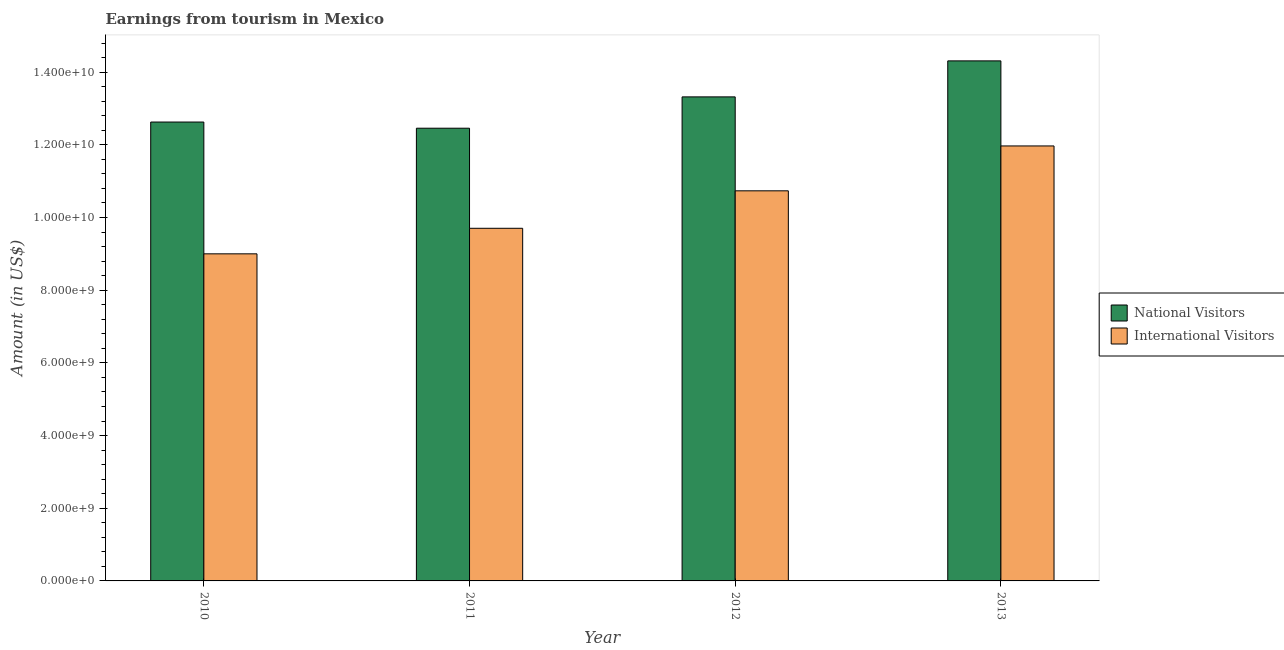How many groups of bars are there?
Your answer should be compact. 4. Are the number of bars per tick equal to the number of legend labels?
Your answer should be very brief. Yes. How many bars are there on the 2nd tick from the left?
Provide a short and direct response. 2. What is the label of the 1st group of bars from the left?
Make the answer very short. 2010. What is the amount earned from international visitors in 2012?
Ensure brevity in your answer.  1.07e+1. Across all years, what is the maximum amount earned from international visitors?
Ensure brevity in your answer.  1.20e+1. Across all years, what is the minimum amount earned from international visitors?
Provide a short and direct response. 9.00e+09. In which year was the amount earned from national visitors maximum?
Make the answer very short. 2013. In which year was the amount earned from international visitors minimum?
Give a very brief answer. 2010. What is the total amount earned from international visitors in the graph?
Keep it short and to the point. 4.14e+1. What is the difference between the amount earned from international visitors in 2012 and that in 2013?
Your response must be concise. -1.24e+09. What is the difference between the amount earned from national visitors in 2013 and the amount earned from international visitors in 2010?
Give a very brief answer. 1.68e+09. What is the average amount earned from international visitors per year?
Offer a very short reply. 1.04e+1. What is the ratio of the amount earned from national visitors in 2012 to that in 2013?
Provide a short and direct response. 0.93. What is the difference between the highest and the second highest amount earned from international visitors?
Your answer should be compact. 1.24e+09. What is the difference between the highest and the lowest amount earned from national visitors?
Your response must be concise. 1.85e+09. What does the 2nd bar from the left in 2013 represents?
Offer a terse response. International Visitors. What does the 2nd bar from the right in 2011 represents?
Your response must be concise. National Visitors. How many bars are there?
Keep it short and to the point. 8. Are all the bars in the graph horizontal?
Keep it short and to the point. No. How many years are there in the graph?
Make the answer very short. 4. Are the values on the major ticks of Y-axis written in scientific E-notation?
Keep it short and to the point. Yes. What is the title of the graph?
Provide a succinct answer. Earnings from tourism in Mexico. What is the label or title of the X-axis?
Provide a short and direct response. Year. What is the label or title of the Y-axis?
Provide a short and direct response. Amount (in US$). What is the Amount (in US$) in National Visitors in 2010?
Provide a succinct answer. 1.26e+1. What is the Amount (in US$) of International Visitors in 2010?
Offer a terse response. 9.00e+09. What is the Amount (in US$) of National Visitors in 2011?
Keep it short and to the point. 1.25e+1. What is the Amount (in US$) in International Visitors in 2011?
Ensure brevity in your answer.  9.70e+09. What is the Amount (in US$) of National Visitors in 2012?
Provide a succinct answer. 1.33e+1. What is the Amount (in US$) in International Visitors in 2012?
Provide a succinct answer. 1.07e+1. What is the Amount (in US$) in National Visitors in 2013?
Offer a terse response. 1.43e+1. What is the Amount (in US$) in International Visitors in 2013?
Provide a short and direct response. 1.20e+1. Across all years, what is the maximum Amount (in US$) in National Visitors?
Offer a very short reply. 1.43e+1. Across all years, what is the maximum Amount (in US$) in International Visitors?
Provide a short and direct response. 1.20e+1. Across all years, what is the minimum Amount (in US$) in National Visitors?
Offer a very short reply. 1.25e+1. Across all years, what is the minimum Amount (in US$) of International Visitors?
Give a very brief answer. 9.00e+09. What is the total Amount (in US$) of National Visitors in the graph?
Make the answer very short. 5.27e+1. What is the total Amount (in US$) in International Visitors in the graph?
Your response must be concise. 4.14e+1. What is the difference between the Amount (in US$) in National Visitors in 2010 and that in 2011?
Your response must be concise. 1.70e+08. What is the difference between the Amount (in US$) in International Visitors in 2010 and that in 2011?
Your response must be concise. -7.03e+08. What is the difference between the Amount (in US$) in National Visitors in 2010 and that in 2012?
Provide a short and direct response. -6.92e+08. What is the difference between the Amount (in US$) in International Visitors in 2010 and that in 2012?
Offer a very short reply. -1.73e+09. What is the difference between the Amount (in US$) in National Visitors in 2010 and that in 2013?
Provide a short and direct response. -1.68e+09. What is the difference between the Amount (in US$) of International Visitors in 2010 and that in 2013?
Provide a short and direct response. -2.97e+09. What is the difference between the Amount (in US$) of National Visitors in 2011 and that in 2012?
Provide a succinct answer. -8.62e+08. What is the difference between the Amount (in US$) in International Visitors in 2011 and that in 2012?
Give a very brief answer. -1.03e+09. What is the difference between the Amount (in US$) of National Visitors in 2011 and that in 2013?
Your answer should be very brief. -1.85e+09. What is the difference between the Amount (in US$) of International Visitors in 2011 and that in 2013?
Offer a terse response. -2.27e+09. What is the difference between the Amount (in US$) of National Visitors in 2012 and that in 2013?
Provide a succinct answer. -9.91e+08. What is the difference between the Amount (in US$) in International Visitors in 2012 and that in 2013?
Your answer should be compact. -1.24e+09. What is the difference between the Amount (in US$) of National Visitors in 2010 and the Amount (in US$) of International Visitors in 2011?
Your response must be concise. 2.92e+09. What is the difference between the Amount (in US$) in National Visitors in 2010 and the Amount (in US$) in International Visitors in 2012?
Provide a succinct answer. 1.89e+09. What is the difference between the Amount (in US$) in National Visitors in 2010 and the Amount (in US$) in International Visitors in 2013?
Offer a terse response. 6.58e+08. What is the difference between the Amount (in US$) in National Visitors in 2011 and the Amount (in US$) in International Visitors in 2012?
Provide a short and direct response. 1.72e+09. What is the difference between the Amount (in US$) in National Visitors in 2011 and the Amount (in US$) in International Visitors in 2013?
Make the answer very short. 4.88e+08. What is the difference between the Amount (in US$) in National Visitors in 2012 and the Amount (in US$) in International Visitors in 2013?
Your answer should be very brief. 1.35e+09. What is the average Amount (in US$) of National Visitors per year?
Your answer should be compact. 1.32e+1. What is the average Amount (in US$) in International Visitors per year?
Provide a short and direct response. 1.04e+1. In the year 2010, what is the difference between the Amount (in US$) of National Visitors and Amount (in US$) of International Visitors?
Give a very brief answer. 3.63e+09. In the year 2011, what is the difference between the Amount (in US$) in National Visitors and Amount (in US$) in International Visitors?
Your answer should be very brief. 2.75e+09. In the year 2012, what is the difference between the Amount (in US$) in National Visitors and Amount (in US$) in International Visitors?
Ensure brevity in your answer.  2.58e+09. In the year 2013, what is the difference between the Amount (in US$) of National Visitors and Amount (in US$) of International Visitors?
Make the answer very short. 2.34e+09. What is the ratio of the Amount (in US$) of National Visitors in 2010 to that in 2011?
Your answer should be very brief. 1.01. What is the ratio of the Amount (in US$) of International Visitors in 2010 to that in 2011?
Ensure brevity in your answer.  0.93. What is the ratio of the Amount (in US$) of National Visitors in 2010 to that in 2012?
Give a very brief answer. 0.95. What is the ratio of the Amount (in US$) of International Visitors in 2010 to that in 2012?
Offer a very short reply. 0.84. What is the ratio of the Amount (in US$) of National Visitors in 2010 to that in 2013?
Offer a very short reply. 0.88. What is the ratio of the Amount (in US$) in International Visitors in 2010 to that in 2013?
Your answer should be compact. 0.75. What is the ratio of the Amount (in US$) of National Visitors in 2011 to that in 2012?
Provide a short and direct response. 0.94. What is the ratio of the Amount (in US$) in International Visitors in 2011 to that in 2012?
Provide a short and direct response. 0.9. What is the ratio of the Amount (in US$) in National Visitors in 2011 to that in 2013?
Keep it short and to the point. 0.87. What is the ratio of the Amount (in US$) in International Visitors in 2011 to that in 2013?
Your response must be concise. 0.81. What is the ratio of the Amount (in US$) in National Visitors in 2012 to that in 2013?
Keep it short and to the point. 0.93. What is the ratio of the Amount (in US$) in International Visitors in 2012 to that in 2013?
Ensure brevity in your answer.  0.9. What is the difference between the highest and the second highest Amount (in US$) of National Visitors?
Ensure brevity in your answer.  9.91e+08. What is the difference between the highest and the second highest Amount (in US$) of International Visitors?
Provide a short and direct response. 1.24e+09. What is the difference between the highest and the lowest Amount (in US$) of National Visitors?
Your answer should be compact. 1.85e+09. What is the difference between the highest and the lowest Amount (in US$) in International Visitors?
Provide a short and direct response. 2.97e+09. 